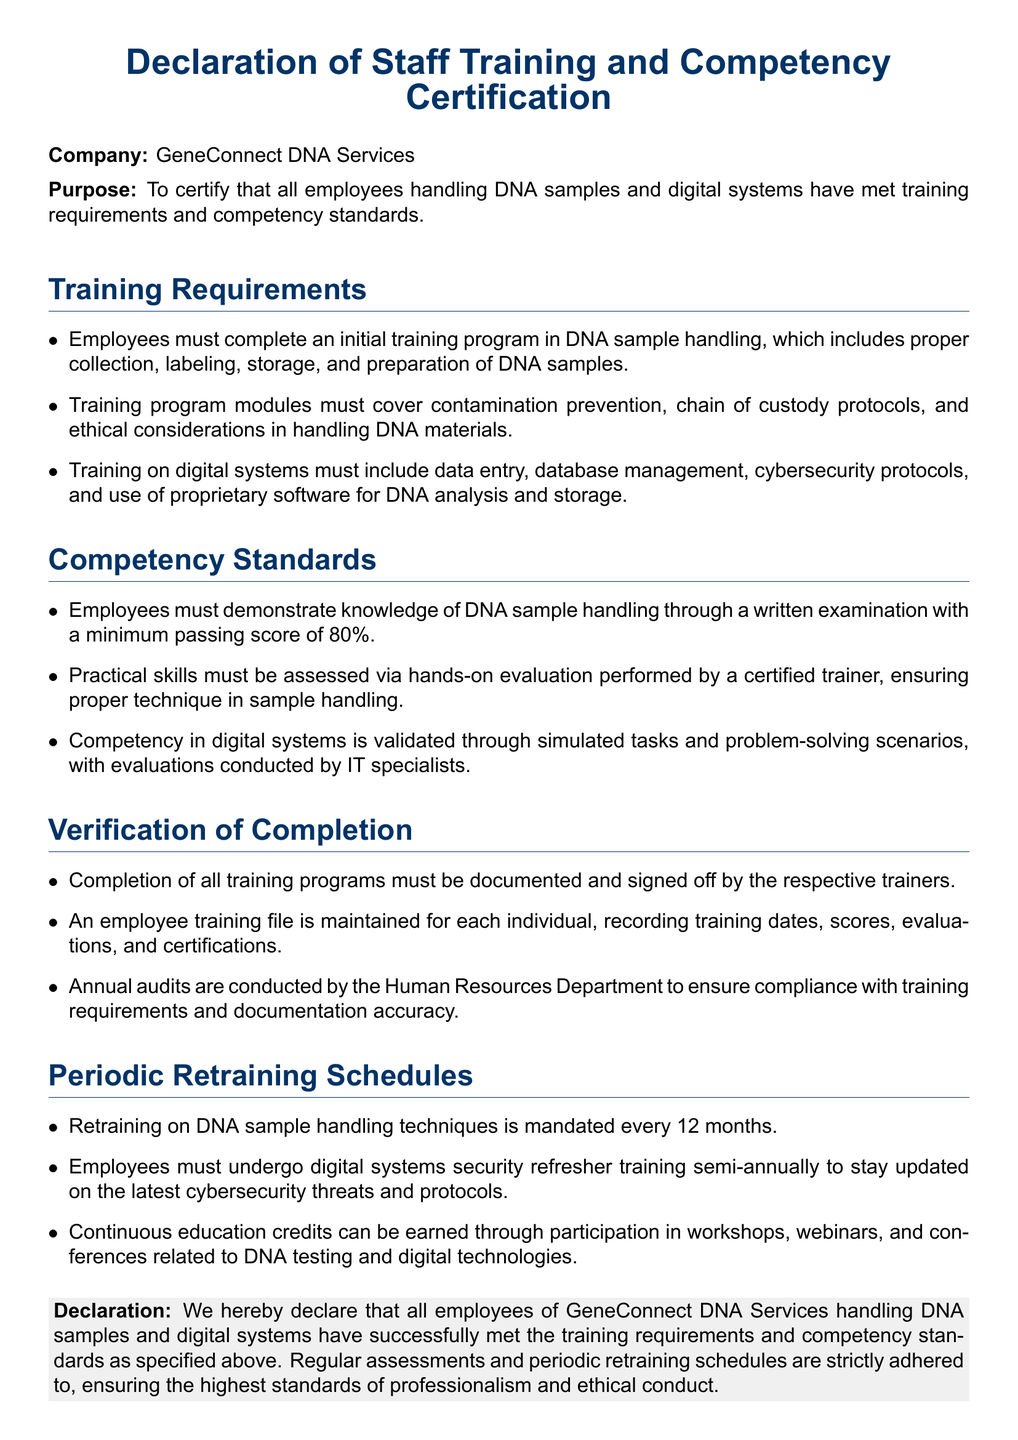What is the name of the company? The name of the company is stated in the document header.
Answer: GeneConnect DNA Services What is the minimum passing score for the written examination? The document specifies the minimum passing score required in the Competency Standards section.
Answer: 80% How often must employees undergo retraining on DNA sample handling techniques? The frequency of mandated retraining is outlined in the Periodic Retraining Schedules section.
Answer: Every 12 months Who performs the practical skills assessment? The document indicates the individual responsible for assessing practical skills in the Competency Standards section.
Answer: Certified trainer What department conducts annual audits for compliance? The document specifies which department is responsible for annual audits in the Verification of Completion section.
Answer: Human Resources Department What is included in the employee training file? The document details the contents of the employee training file under Verification of Completion.
Answer: Training dates, scores, evaluations, and certifications What is the purpose of this declaration? The purpose is outlined at the beginning of the document, specifying what it aims to certify.
Answer: To certify that all employees handling DNA samples and digital systems have met training requirements and competency standards How frequently must digital systems security refresher training occur? The frequency for refresher training on digital systems is specified in the Periodic Retraining Schedules.
Answer: Semi-annually 